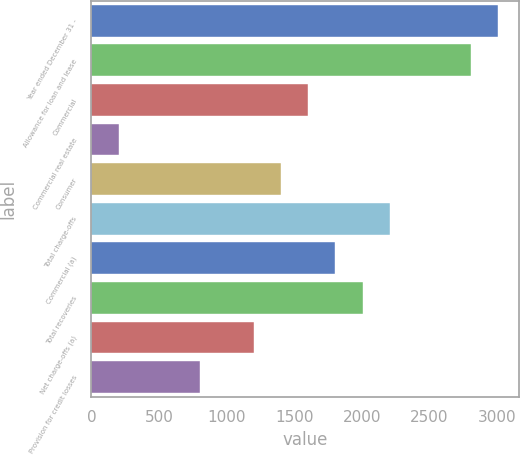Convert chart. <chart><loc_0><loc_0><loc_500><loc_500><bar_chart><fcel>Year ended December 31 -<fcel>Allowance for loan and lease<fcel>Commercial<fcel>Commercial real estate<fcel>Consumer<fcel>Total charge-offs<fcel>Commercial (a)<fcel>Total recoveries<fcel>Net charge-offs (a)<fcel>Provision for credit losses<nl><fcel>3007.54<fcel>2807.04<fcel>1604.04<fcel>200.54<fcel>1403.54<fcel>2205.54<fcel>1804.54<fcel>2005.04<fcel>1203.04<fcel>802.04<nl></chart> 